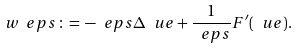Convert formula to latex. <formula><loc_0><loc_0><loc_500><loc_500>w _ { \ } e p s \, \colon = \, - \ e p s \Delta \ u e + \frac { 1 } { \ e p s } F ^ { \prime } ( \ u e ) .</formula> 